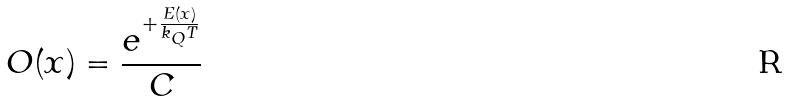<formula> <loc_0><loc_0><loc_500><loc_500>O ( x ) = \frac { e ^ { + \frac { E ( x ) } { k _ { Q } T } } } { C }</formula> 